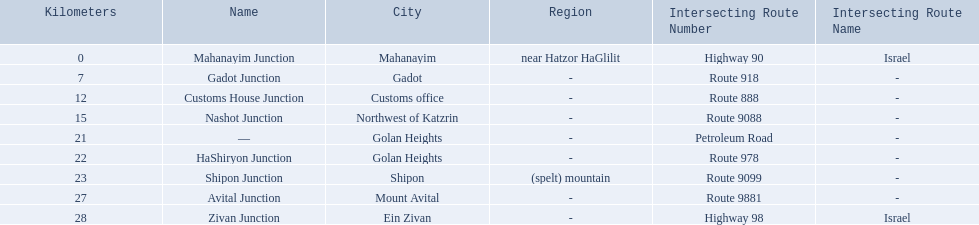Which junctions are located on numbered routes, and not highways or other types? Gadot Junction, Customs House Junction, Nashot Junction, HaShiryon Junction, Shipon Junction, Avital Junction. Of these junctions, which ones are located on routes with four digits (ex. route 9999)? Nashot Junction, Shipon Junction, Avital Junction. Of the remaining routes, which is located on shipon (spelt) mountain? Shipon Junction. Can you parse all the data within this table? {'header': ['Kilometers', 'Name', 'City', 'Region', 'Intersecting Route Number', 'Intersecting Route Name'], 'rows': [['0', 'Mahanayim Junction', 'Mahanayim', 'near Hatzor HaGlilit', 'Highway 90', 'Israel'], ['7', 'Gadot Junction', 'Gadot', '-', 'Route 918', '-'], ['12', 'Customs House Junction', 'Customs office', '-', 'Route 888', '-'], ['15', 'Nashot Junction', 'Northwest of Katzrin', '-', 'Route 9088', '-'], ['21', '—', 'Golan Heights', '-', 'Petroleum Road', '-'], ['22', 'HaShiryon Junction', 'Golan Heights', '-', 'Route 978', '-'], ['23', 'Shipon Junction', 'Shipon', '(spelt) mountain', 'Route 9099', '-'], ['27', 'Avital Junction', 'Mount Avital', '-', 'Route 9881', '-'], ['28', 'Zivan Junction', 'Ein Zivan', '-', 'Highway 98', 'Israel']]} Which intersecting routes are route 918 Route 918. What is the name? Gadot Junction. 